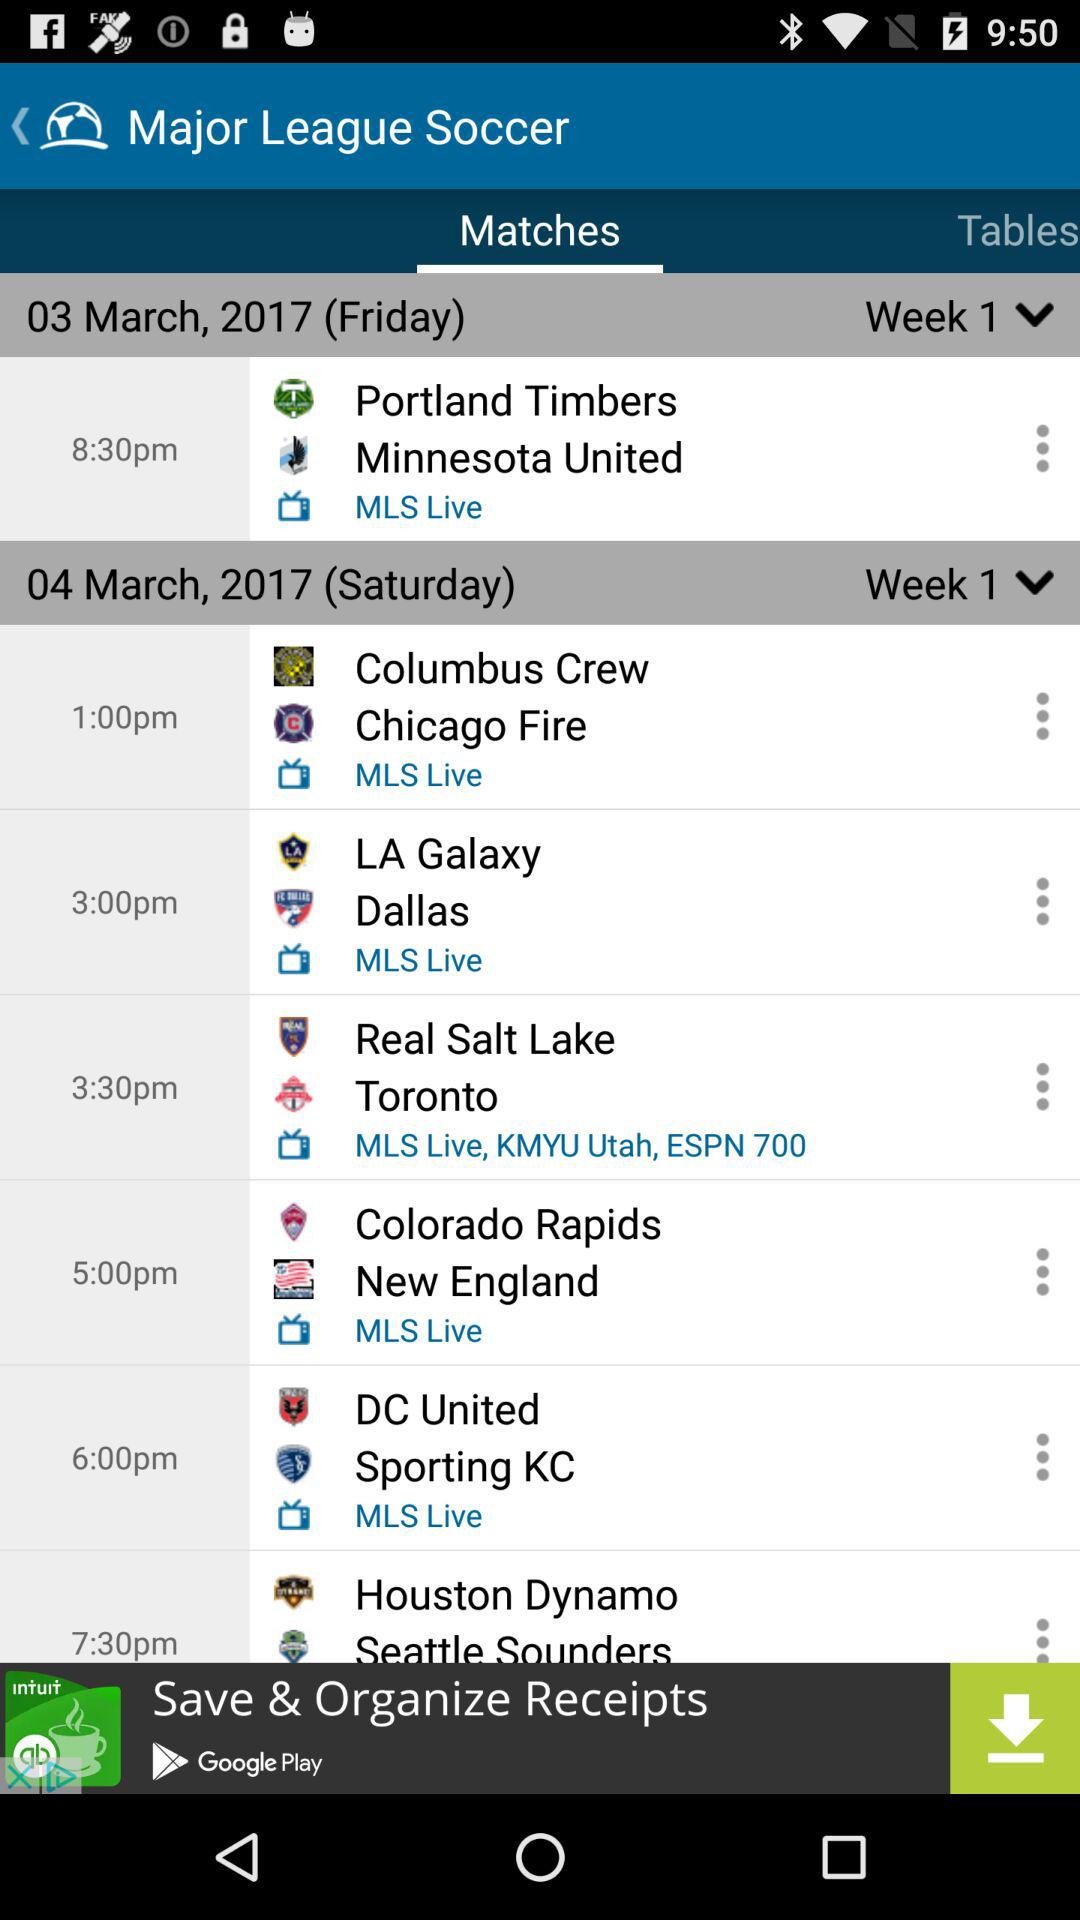On what date will the Real Salt Lake vs. Toronto match be played? The date of the match will be Saturday, March 4, 2017. 